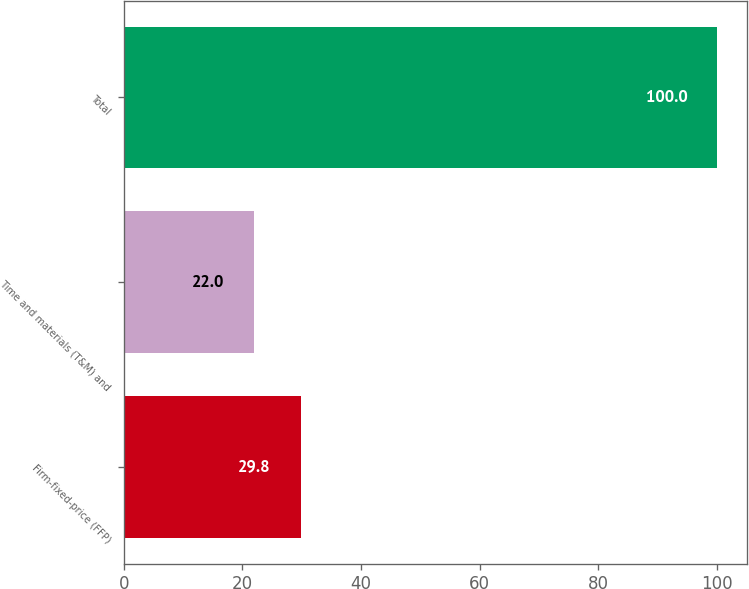Convert chart to OTSL. <chart><loc_0><loc_0><loc_500><loc_500><bar_chart><fcel>Firm-fixed-price (FFP)<fcel>Time and materials (T&M) and<fcel>Total<nl><fcel>29.8<fcel>22<fcel>100<nl></chart> 